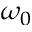<formula> <loc_0><loc_0><loc_500><loc_500>\omega _ { 0 }</formula> 